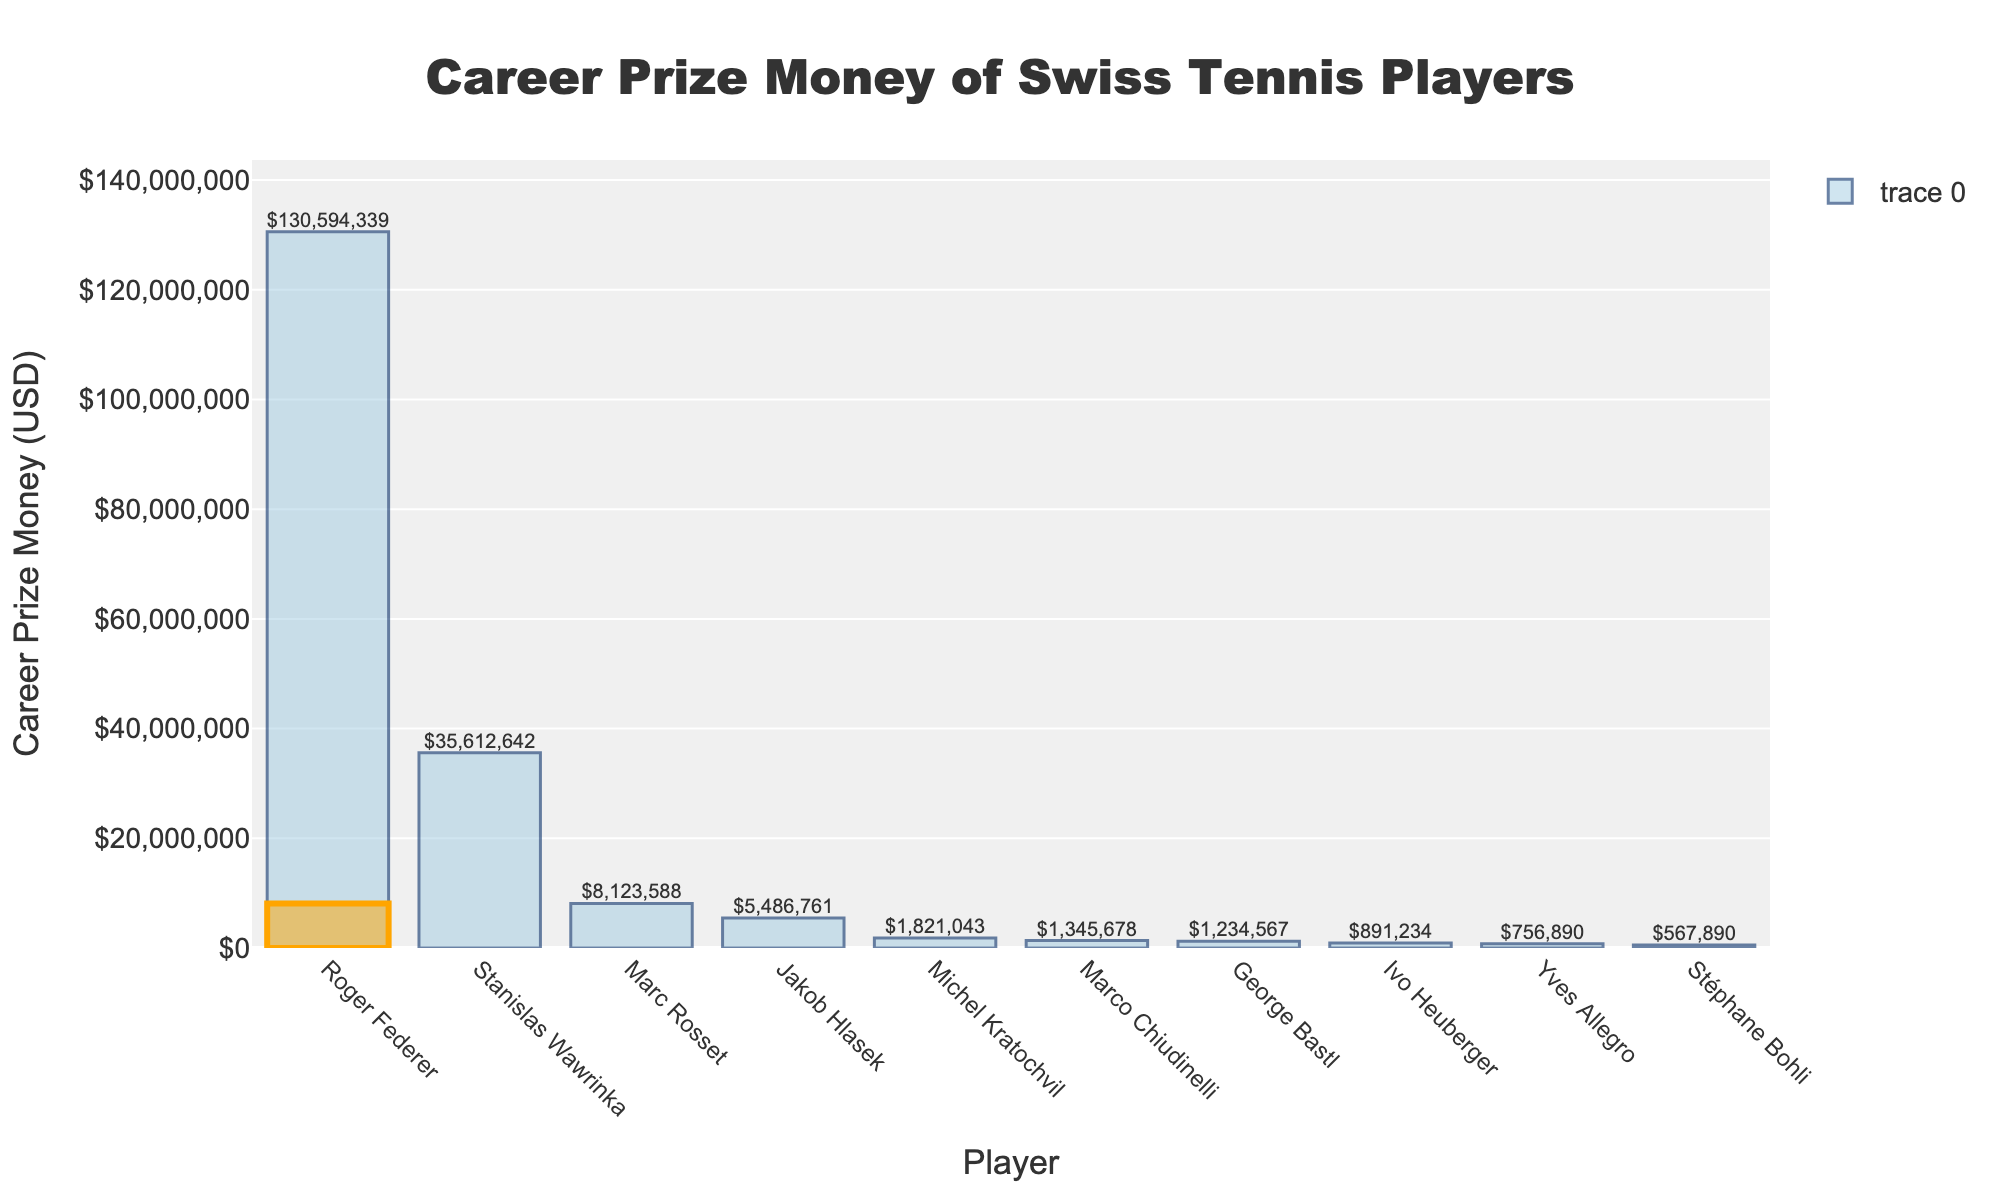who has the highest career prize money earnings? From the figure, observe the bar heights and locate the one reaching the highest value on the y-axis. The player associated with this bar has the highest earnings.
Answer: Roger Federer who has the lowest career prize money earnings? Identify the shortest bar in the figure, which indicates the player with the lowest earnings.
Answer: Stéphane Bohli compare Marc Rosset's earnings to Roger Federer's earnings. How much less has Marc Rosset earned? Find the heights of Marc Rosset's and Roger Federer's bars, which represent their earnings. Subtract Marc's earnings from Roger's earnings.
Answer: $122,470,751 what is the combined earnings of the top three players? Identify the three highest bars and sum the values represented by these bars. The players are Roger Federer, Stanislas Wawrinka, and Marc Rosset.
Answer: $174,874,569 how does Jakob Hlasek's earnings compare to Stanislas Wawrinka's earnings? Find the heights of Jakob Hlasek's and Stanislas Wawrinka's bars. Determine the difference by subtracting Jakob's earnings from Stanislas's earnings.
Answer: $30,745,881 which player has about half of Marc Rosset's earnings? Compare the heights of Marc Rosset's bar with others to find a player whose bar is approximately half.
Answer: Jakob Hlasek how many players earned more than $5,000,000? Count the bars that extend above the $5,000,000 mark on the y-axis.
Answer: 3 what's the total career prize money earned by all players combined? Sum the heights of all bars, which represent the earnings of each player.
Answer: $183,487,828 how does the highlighted bar differ from the others? Observe the visual attributes of the highlighted bar which pertains to Marc Rosset. Unlike other bars, it is colored distinctly and outlined in orange.
Answer: It is highlighted in orange which player closest to $2,000,000 in earnings? Examine the heights of the bars to find the one nearest to the $2,000,000 mark on the y-axis.
Answer: Michel Kratochvil 